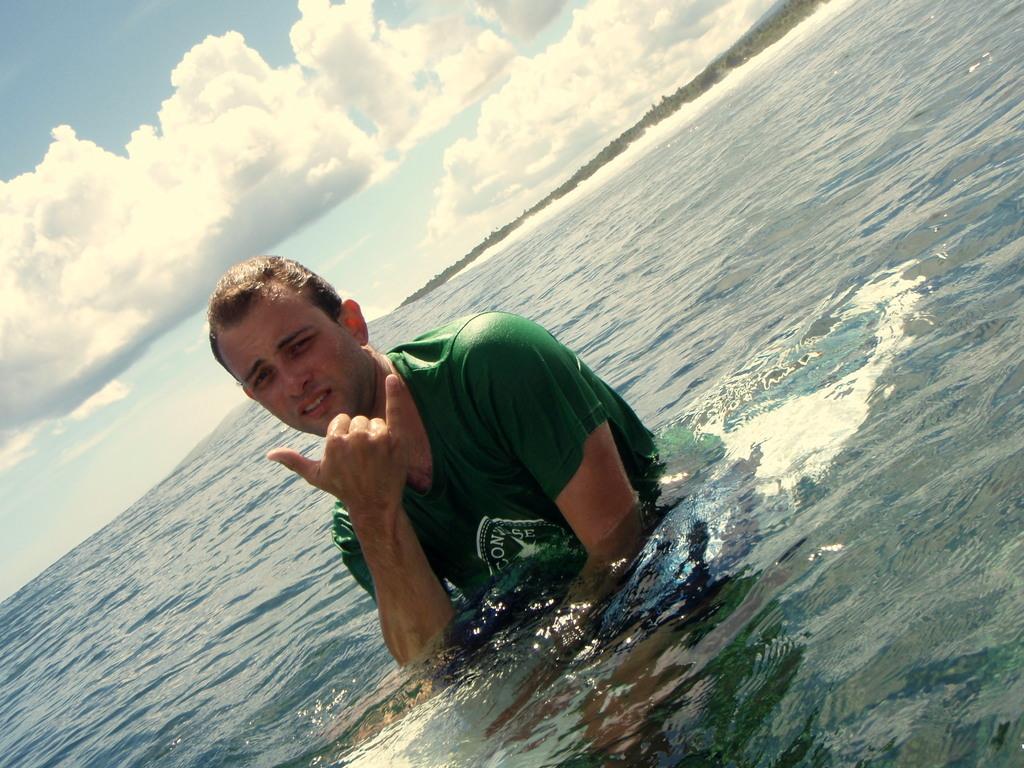Could you give a brief overview of what you see in this image? In this picture I can see there is a man standing in the ocean and he is wearing a green t-shirt and in the backdrop there are trees and the sky is clear. 